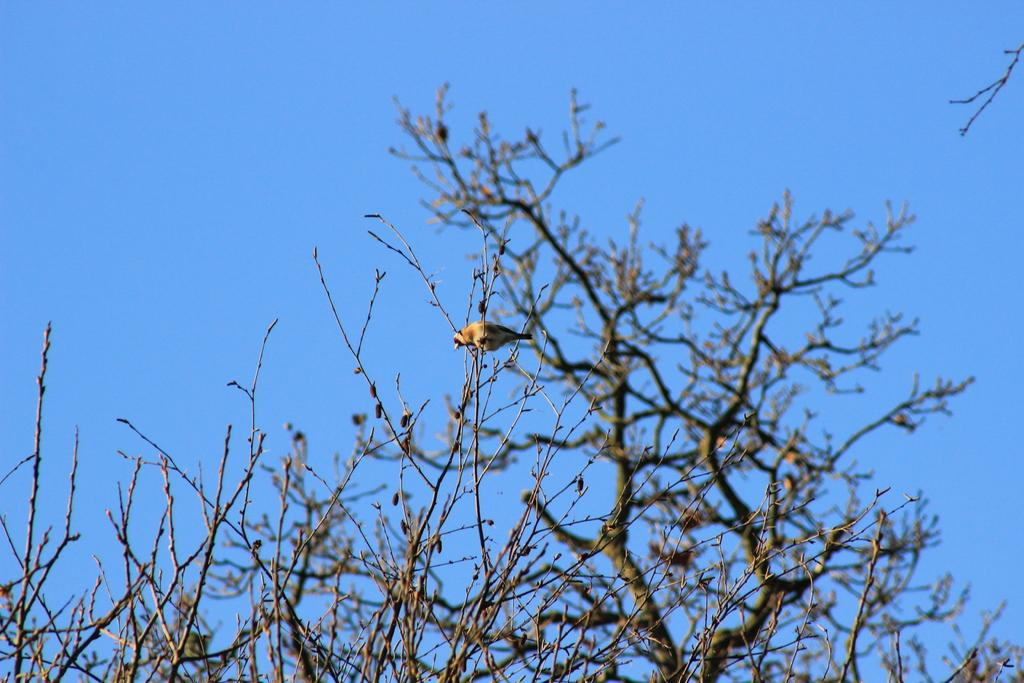What type of animal can be seen in the image? There is a bird in the image. Where is the bird located in the image? The bird is present on the branches of a tree. What type of ghost is visible in the image? There is no ghost present in the image; it features a bird on the branches of a tree. What type of rifle can be seen in the image? There is no rifle present in the image. 